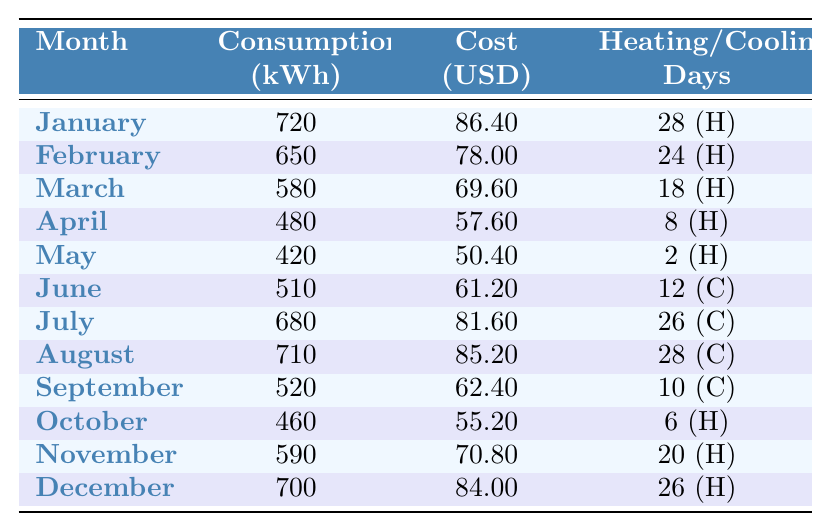What was the highest electricity consumption recorded in a month? The highest consumption is found in January with 720 kWh.
Answer: 720 kWh Which month had the lowest cost for electricity? The lowest cost is in May, which is $50.40.
Answer: $50.40 How many cooling days were recorded in July? July had 26 cooling days, as indicated in the table.
Answer: 26 What is the average monthly electricity consumption over the year? To find the average, sum all the monthly consumptions (720+650+580+480+420+510+680+710+520+460+590+700 = 6,740) and divide by 12. The average is 6,740 / 12 = 561.67 kWh.
Answer: 561.67 kWh In which month did the consumption drop below 500 kWh? The consumption dropped below 500 kWh in April, with a recorded use of 480 kWh.
Answer: April Was there any month without heating days? Yes, June did not have any heating days, as it only has cooling days.
Answer: Yes What was the difference in consumption between January and May? To find the difference, subtract May's consumption from January's: 720 kWh - 420 kWh = 300 kWh.
Answer: 300 kWh Which two consecutive months had the greatest increase in consumption? The greatest increase occurred between June (510 kWh) and July (680 kWh), an increase of 170 kWh.
Answer: June to July Did the household's electricity costs generally increase from January to December? No, the costs did not consistently increase; they fluctuated, with lower costs observed in spring and summer months compared to winter and late fall.
Answer: No What was the total cost of electricity for the entire year? Add up each month's cost: $86.40 + $78.00 + $69.60 + $57.60 + $50.40 + $61.20 + $81.60 + $85.20 + $62.40 + $55.20 + $70.80 + $84.00 = $3070.80.
Answer: $1,070.80 